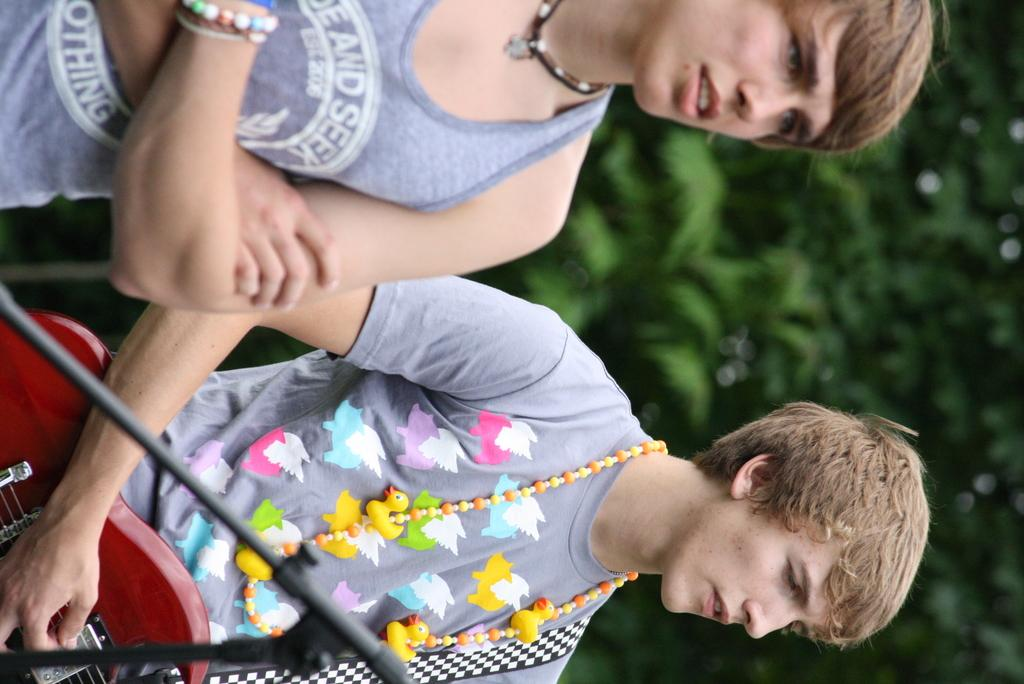What is the main subject of the image? There is a woman standing in the image. Can you describe the actions of the person in the image? There is a person standing in the image, and they are playing gutter. What is the gender of the person playing gutter? The person playing gutter is a woman. What type of shirt is the woman wearing during her journey in the image? There is no reference to a journey or a shirt in the image, so it's not possible to determine what type of shirt the woman might be wearing. 